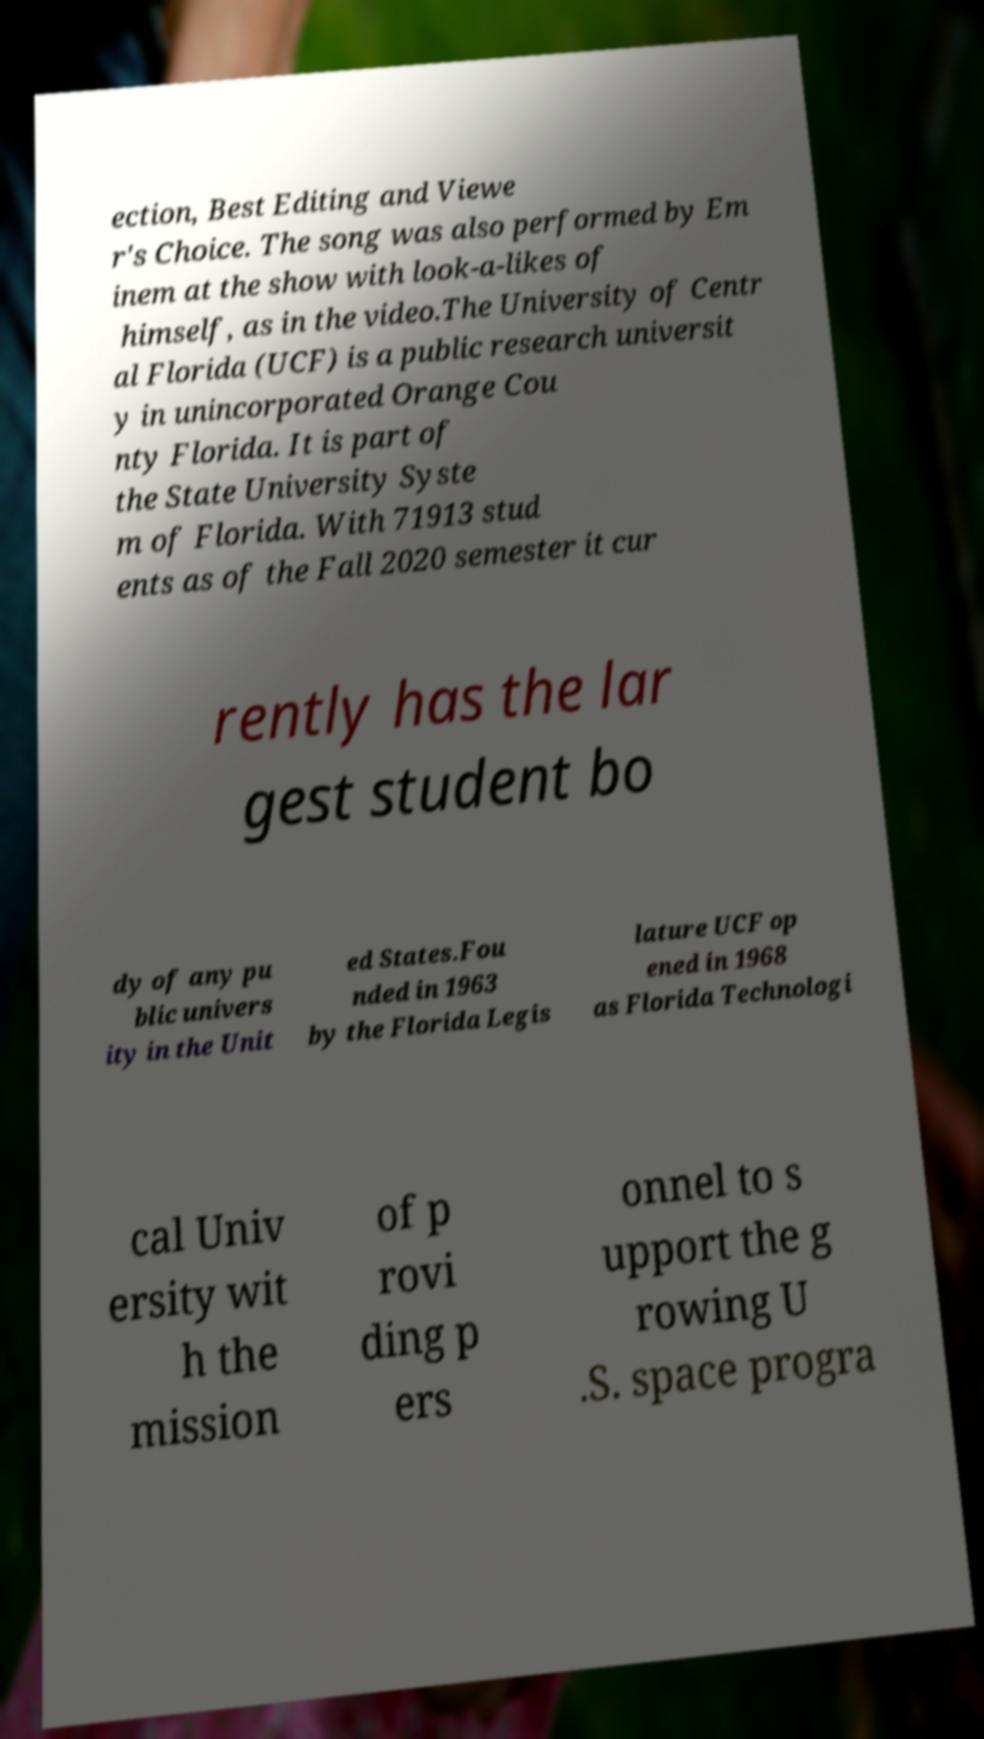Could you extract and type out the text from this image? ection, Best Editing and Viewe r's Choice. The song was also performed by Em inem at the show with look-a-likes of himself, as in the video.The University of Centr al Florida (UCF) is a public research universit y in unincorporated Orange Cou nty Florida. It is part of the State University Syste m of Florida. With 71913 stud ents as of the Fall 2020 semester it cur rently has the lar gest student bo dy of any pu blic univers ity in the Unit ed States.Fou nded in 1963 by the Florida Legis lature UCF op ened in 1968 as Florida Technologi cal Univ ersity wit h the mission of p rovi ding p ers onnel to s upport the g rowing U .S. space progra 